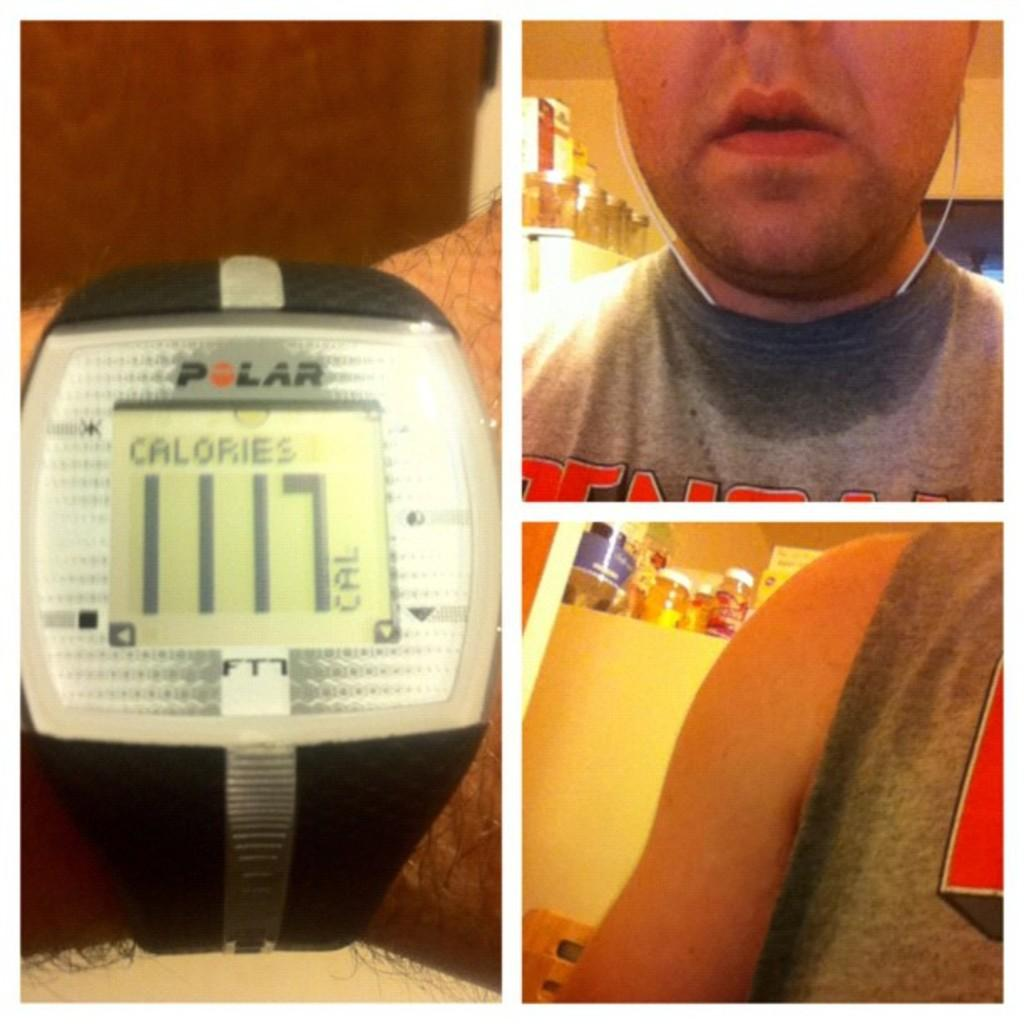<image>
Give a short and clear explanation of the subsequent image. A watch shows 1117 calories on the digital screen. 